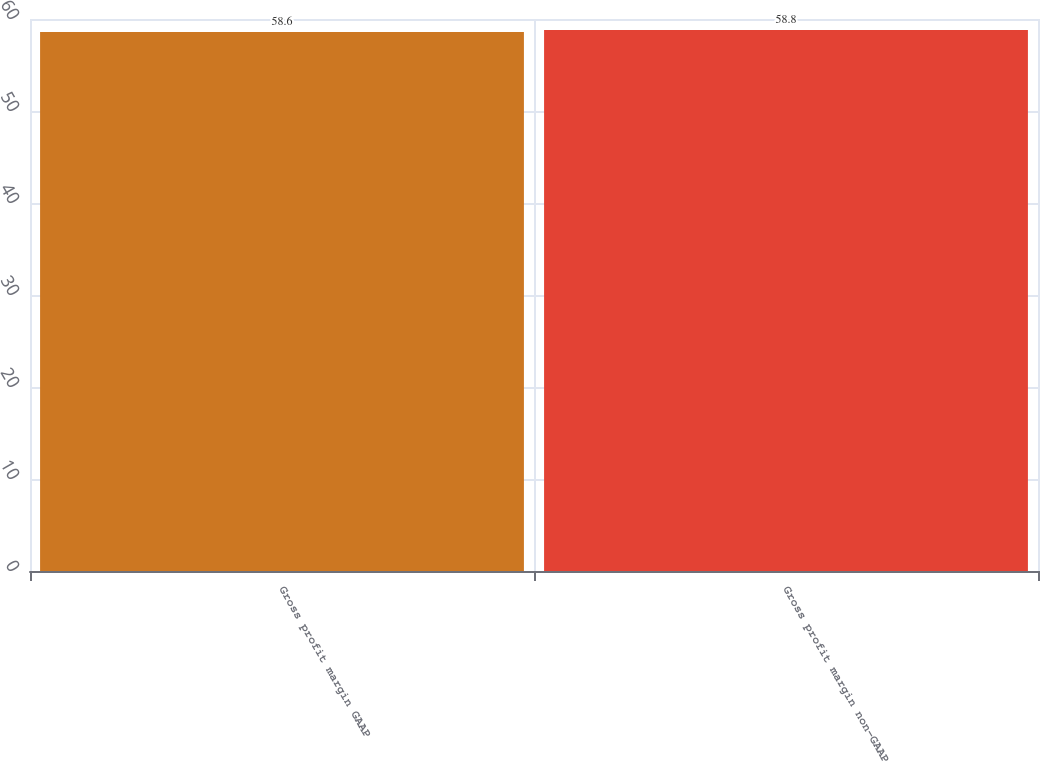<chart> <loc_0><loc_0><loc_500><loc_500><bar_chart><fcel>Gross profit margin GAAP<fcel>Gross profit margin non-GAAP<nl><fcel>58.6<fcel>58.8<nl></chart> 